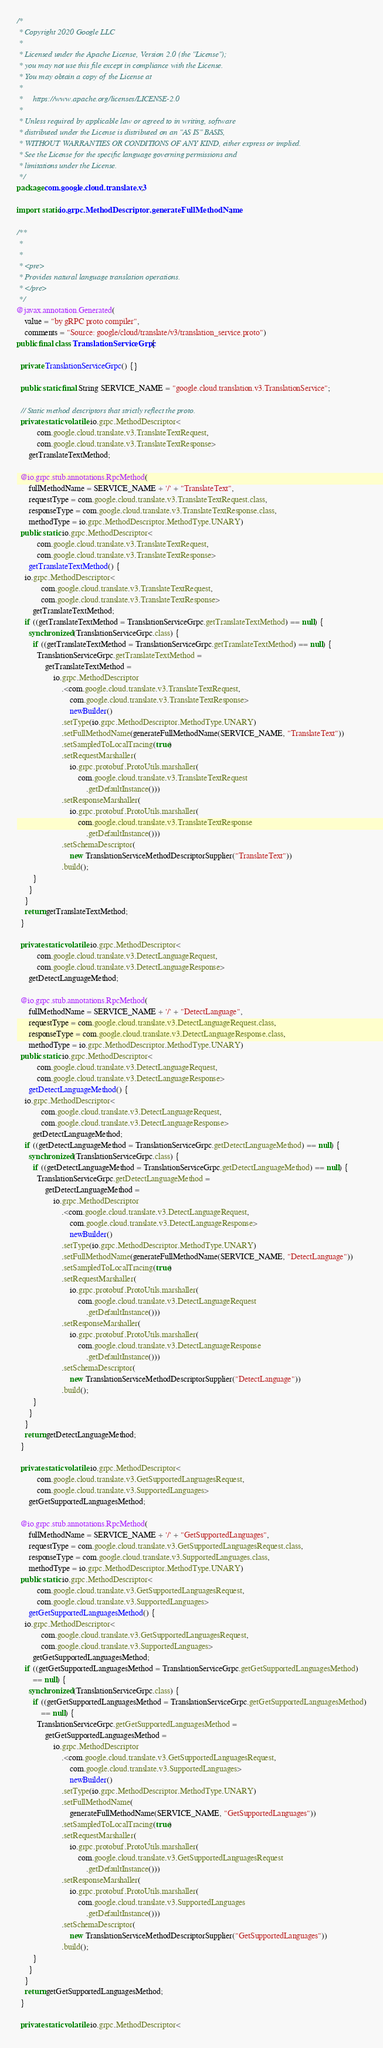Convert code to text. <code><loc_0><loc_0><loc_500><loc_500><_Java_>/*
 * Copyright 2020 Google LLC
 *
 * Licensed under the Apache License, Version 2.0 (the "License");
 * you may not use this file except in compliance with the License.
 * You may obtain a copy of the License at
 *
 *     https://www.apache.org/licenses/LICENSE-2.0
 *
 * Unless required by applicable law or agreed to in writing, software
 * distributed under the License is distributed on an "AS IS" BASIS,
 * WITHOUT WARRANTIES OR CONDITIONS OF ANY KIND, either express or implied.
 * See the License for the specific language governing permissions and
 * limitations under the License.
 */
package com.google.cloud.translate.v3;

import static io.grpc.MethodDescriptor.generateFullMethodName;

/**
 *
 *
 * <pre>
 * Provides natural language translation operations.
 * </pre>
 */
@javax.annotation.Generated(
    value = "by gRPC proto compiler",
    comments = "Source: google/cloud/translate/v3/translation_service.proto")
public final class TranslationServiceGrpc {

  private TranslationServiceGrpc() {}

  public static final String SERVICE_NAME = "google.cloud.translation.v3.TranslationService";

  // Static method descriptors that strictly reflect the proto.
  private static volatile io.grpc.MethodDescriptor<
          com.google.cloud.translate.v3.TranslateTextRequest,
          com.google.cloud.translate.v3.TranslateTextResponse>
      getTranslateTextMethod;

  @io.grpc.stub.annotations.RpcMethod(
      fullMethodName = SERVICE_NAME + '/' + "TranslateText",
      requestType = com.google.cloud.translate.v3.TranslateTextRequest.class,
      responseType = com.google.cloud.translate.v3.TranslateTextResponse.class,
      methodType = io.grpc.MethodDescriptor.MethodType.UNARY)
  public static io.grpc.MethodDescriptor<
          com.google.cloud.translate.v3.TranslateTextRequest,
          com.google.cloud.translate.v3.TranslateTextResponse>
      getTranslateTextMethod() {
    io.grpc.MethodDescriptor<
            com.google.cloud.translate.v3.TranslateTextRequest,
            com.google.cloud.translate.v3.TranslateTextResponse>
        getTranslateTextMethod;
    if ((getTranslateTextMethod = TranslationServiceGrpc.getTranslateTextMethod) == null) {
      synchronized (TranslationServiceGrpc.class) {
        if ((getTranslateTextMethod = TranslationServiceGrpc.getTranslateTextMethod) == null) {
          TranslationServiceGrpc.getTranslateTextMethod =
              getTranslateTextMethod =
                  io.grpc.MethodDescriptor
                      .<com.google.cloud.translate.v3.TranslateTextRequest,
                          com.google.cloud.translate.v3.TranslateTextResponse>
                          newBuilder()
                      .setType(io.grpc.MethodDescriptor.MethodType.UNARY)
                      .setFullMethodName(generateFullMethodName(SERVICE_NAME, "TranslateText"))
                      .setSampledToLocalTracing(true)
                      .setRequestMarshaller(
                          io.grpc.protobuf.ProtoUtils.marshaller(
                              com.google.cloud.translate.v3.TranslateTextRequest
                                  .getDefaultInstance()))
                      .setResponseMarshaller(
                          io.grpc.protobuf.ProtoUtils.marshaller(
                              com.google.cloud.translate.v3.TranslateTextResponse
                                  .getDefaultInstance()))
                      .setSchemaDescriptor(
                          new TranslationServiceMethodDescriptorSupplier("TranslateText"))
                      .build();
        }
      }
    }
    return getTranslateTextMethod;
  }

  private static volatile io.grpc.MethodDescriptor<
          com.google.cloud.translate.v3.DetectLanguageRequest,
          com.google.cloud.translate.v3.DetectLanguageResponse>
      getDetectLanguageMethod;

  @io.grpc.stub.annotations.RpcMethod(
      fullMethodName = SERVICE_NAME + '/' + "DetectLanguage",
      requestType = com.google.cloud.translate.v3.DetectLanguageRequest.class,
      responseType = com.google.cloud.translate.v3.DetectLanguageResponse.class,
      methodType = io.grpc.MethodDescriptor.MethodType.UNARY)
  public static io.grpc.MethodDescriptor<
          com.google.cloud.translate.v3.DetectLanguageRequest,
          com.google.cloud.translate.v3.DetectLanguageResponse>
      getDetectLanguageMethod() {
    io.grpc.MethodDescriptor<
            com.google.cloud.translate.v3.DetectLanguageRequest,
            com.google.cloud.translate.v3.DetectLanguageResponse>
        getDetectLanguageMethod;
    if ((getDetectLanguageMethod = TranslationServiceGrpc.getDetectLanguageMethod) == null) {
      synchronized (TranslationServiceGrpc.class) {
        if ((getDetectLanguageMethod = TranslationServiceGrpc.getDetectLanguageMethod) == null) {
          TranslationServiceGrpc.getDetectLanguageMethod =
              getDetectLanguageMethod =
                  io.grpc.MethodDescriptor
                      .<com.google.cloud.translate.v3.DetectLanguageRequest,
                          com.google.cloud.translate.v3.DetectLanguageResponse>
                          newBuilder()
                      .setType(io.grpc.MethodDescriptor.MethodType.UNARY)
                      .setFullMethodName(generateFullMethodName(SERVICE_NAME, "DetectLanguage"))
                      .setSampledToLocalTracing(true)
                      .setRequestMarshaller(
                          io.grpc.protobuf.ProtoUtils.marshaller(
                              com.google.cloud.translate.v3.DetectLanguageRequest
                                  .getDefaultInstance()))
                      .setResponseMarshaller(
                          io.grpc.protobuf.ProtoUtils.marshaller(
                              com.google.cloud.translate.v3.DetectLanguageResponse
                                  .getDefaultInstance()))
                      .setSchemaDescriptor(
                          new TranslationServiceMethodDescriptorSupplier("DetectLanguage"))
                      .build();
        }
      }
    }
    return getDetectLanguageMethod;
  }

  private static volatile io.grpc.MethodDescriptor<
          com.google.cloud.translate.v3.GetSupportedLanguagesRequest,
          com.google.cloud.translate.v3.SupportedLanguages>
      getGetSupportedLanguagesMethod;

  @io.grpc.stub.annotations.RpcMethod(
      fullMethodName = SERVICE_NAME + '/' + "GetSupportedLanguages",
      requestType = com.google.cloud.translate.v3.GetSupportedLanguagesRequest.class,
      responseType = com.google.cloud.translate.v3.SupportedLanguages.class,
      methodType = io.grpc.MethodDescriptor.MethodType.UNARY)
  public static io.grpc.MethodDescriptor<
          com.google.cloud.translate.v3.GetSupportedLanguagesRequest,
          com.google.cloud.translate.v3.SupportedLanguages>
      getGetSupportedLanguagesMethod() {
    io.grpc.MethodDescriptor<
            com.google.cloud.translate.v3.GetSupportedLanguagesRequest,
            com.google.cloud.translate.v3.SupportedLanguages>
        getGetSupportedLanguagesMethod;
    if ((getGetSupportedLanguagesMethod = TranslationServiceGrpc.getGetSupportedLanguagesMethod)
        == null) {
      synchronized (TranslationServiceGrpc.class) {
        if ((getGetSupportedLanguagesMethod = TranslationServiceGrpc.getGetSupportedLanguagesMethod)
            == null) {
          TranslationServiceGrpc.getGetSupportedLanguagesMethod =
              getGetSupportedLanguagesMethod =
                  io.grpc.MethodDescriptor
                      .<com.google.cloud.translate.v3.GetSupportedLanguagesRequest,
                          com.google.cloud.translate.v3.SupportedLanguages>
                          newBuilder()
                      .setType(io.grpc.MethodDescriptor.MethodType.UNARY)
                      .setFullMethodName(
                          generateFullMethodName(SERVICE_NAME, "GetSupportedLanguages"))
                      .setSampledToLocalTracing(true)
                      .setRequestMarshaller(
                          io.grpc.protobuf.ProtoUtils.marshaller(
                              com.google.cloud.translate.v3.GetSupportedLanguagesRequest
                                  .getDefaultInstance()))
                      .setResponseMarshaller(
                          io.grpc.protobuf.ProtoUtils.marshaller(
                              com.google.cloud.translate.v3.SupportedLanguages
                                  .getDefaultInstance()))
                      .setSchemaDescriptor(
                          new TranslationServiceMethodDescriptorSupplier("GetSupportedLanguages"))
                      .build();
        }
      }
    }
    return getGetSupportedLanguagesMethod;
  }

  private static volatile io.grpc.MethodDescriptor<</code> 